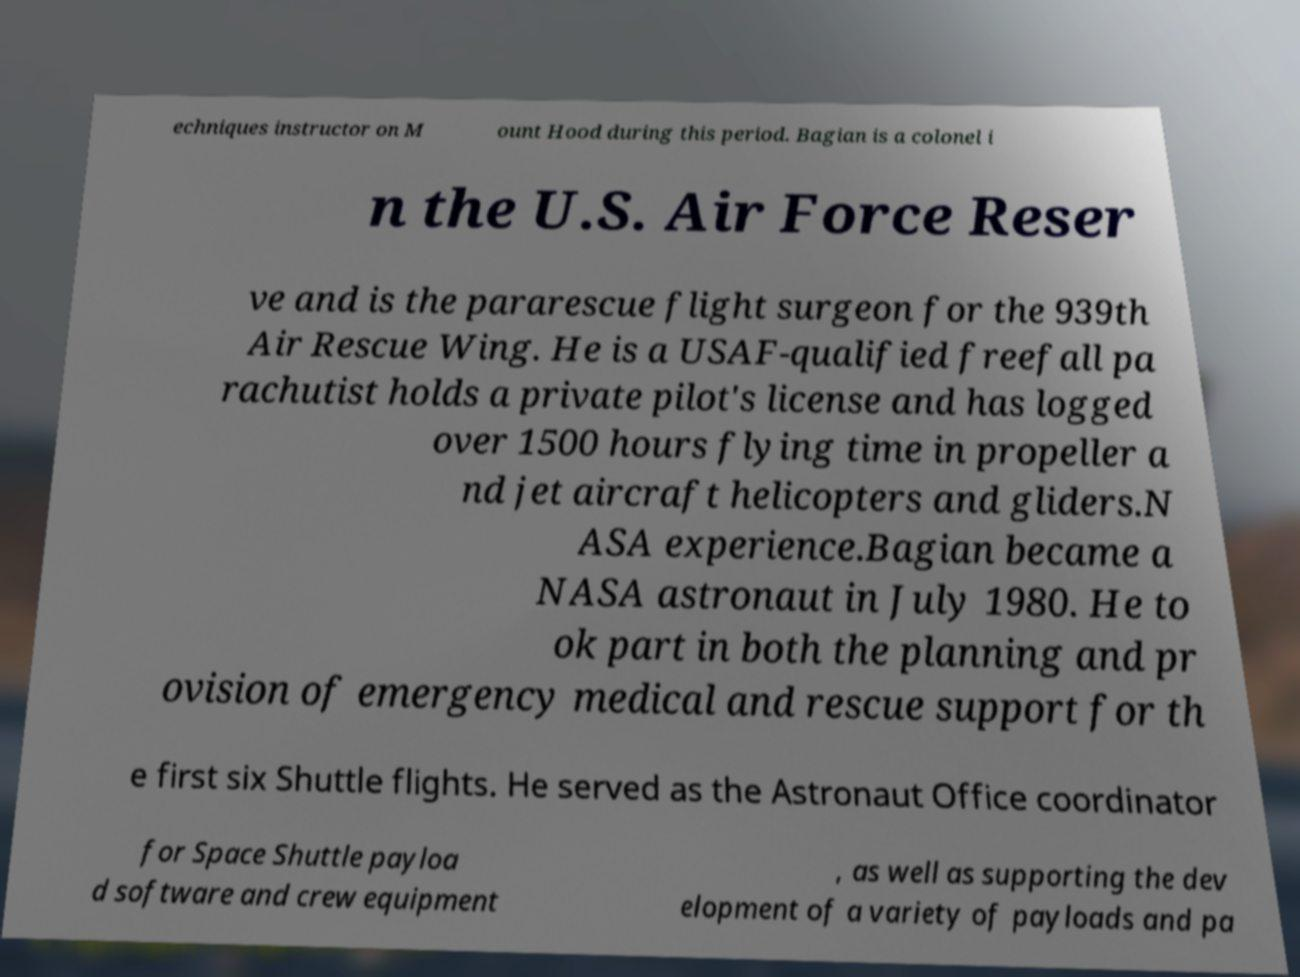Could you extract and type out the text from this image? echniques instructor on M ount Hood during this period. Bagian is a colonel i n the U.S. Air Force Reser ve and is the pararescue flight surgeon for the 939th Air Rescue Wing. He is a USAF-qualified freefall pa rachutist holds a private pilot's license and has logged over 1500 hours flying time in propeller a nd jet aircraft helicopters and gliders.N ASA experience.Bagian became a NASA astronaut in July 1980. He to ok part in both the planning and pr ovision of emergency medical and rescue support for th e first six Shuttle flights. He served as the Astronaut Office coordinator for Space Shuttle payloa d software and crew equipment , as well as supporting the dev elopment of a variety of payloads and pa 